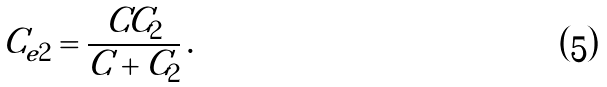Convert formula to latex. <formula><loc_0><loc_0><loc_500><loc_500>C _ { e 2 } = \frac { C C _ { 2 } } { C + C _ { 2 } } \, .</formula> 